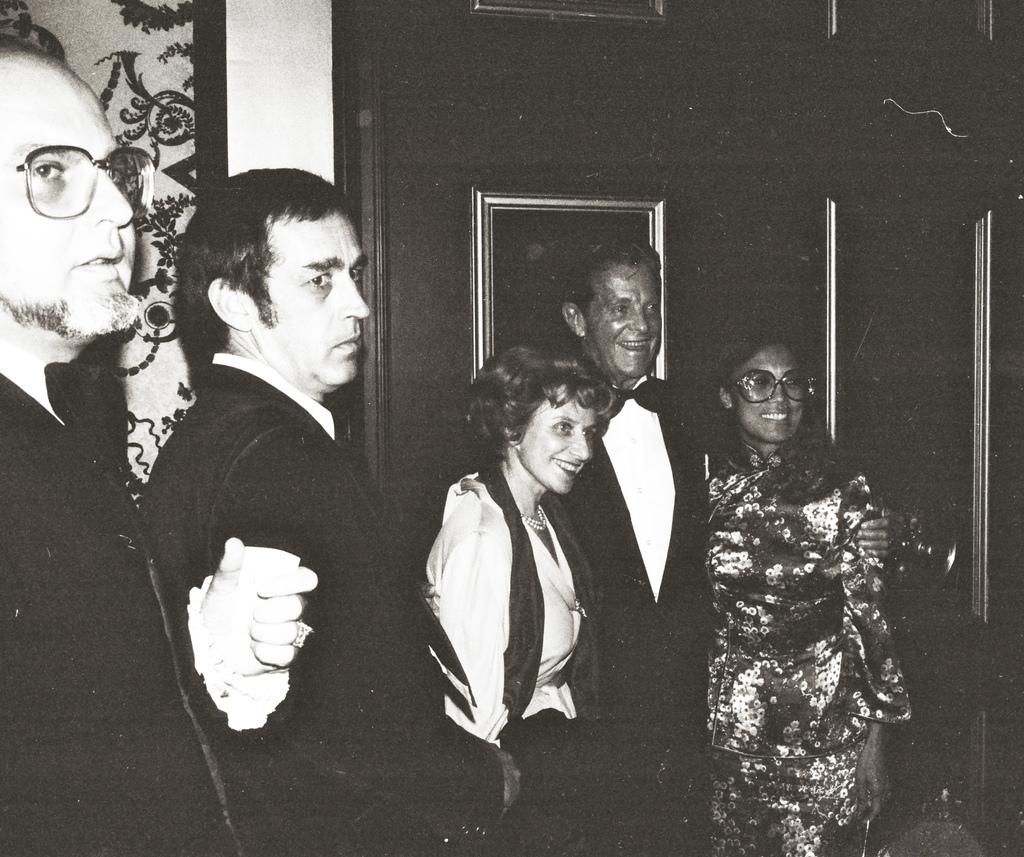What is the color scheme of the image? The image is black and white. How many men are in the image? There are three men in the image. How many women are in the image? There are two women in the image. Can you describe the background of the image? There may be a wall in the background of the image. Is there any additional feature on the wall in the background? There may be a mirror attached to the wall in the background of the image. Can you see any quicksand in the image? There is no quicksand present in the image. What type of birds can be seen flying in the image? There are no birds visible in the image. 